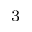Convert formula to latex. <formula><loc_0><loc_0><loc_500><loc_500>^ { - 3 }</formula> 